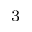Convert formula to latex. <formula><loc_0><loc_0><loc_500><loc_500>^ { - 3 }</formula> 